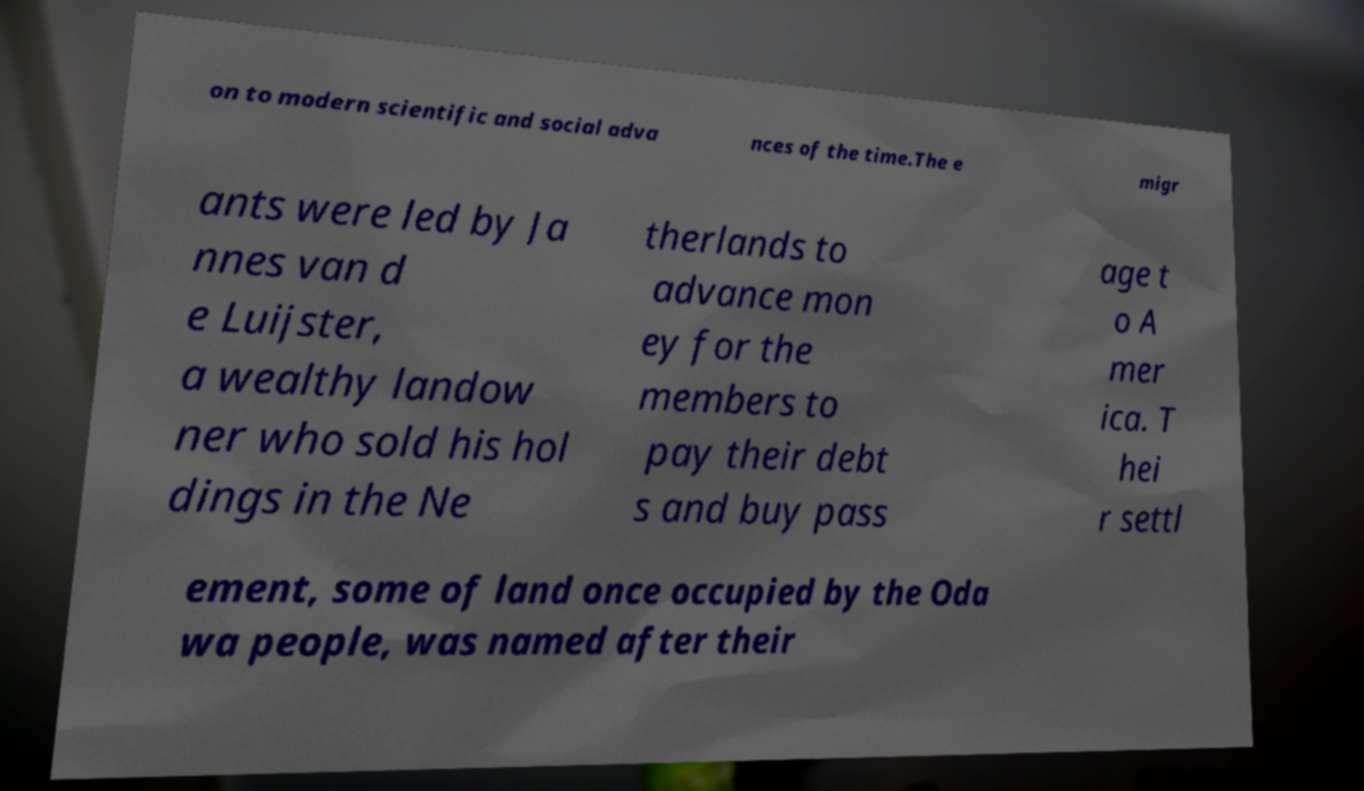There's text embedded in this image that I need extracted. Can you transcribe it verbatim? on to modern scientific and social adva nces of the time.The e migr ants were led by Ja nnes van d e Luijster, a wealthy landow ner who sold his hol dings in the Ne therlands to advance mon ey for the members to pay their debt s and buy pass age t o A mer ica. T hei r settl ement, some of land once occupied by the Oda wa people, was named after their 